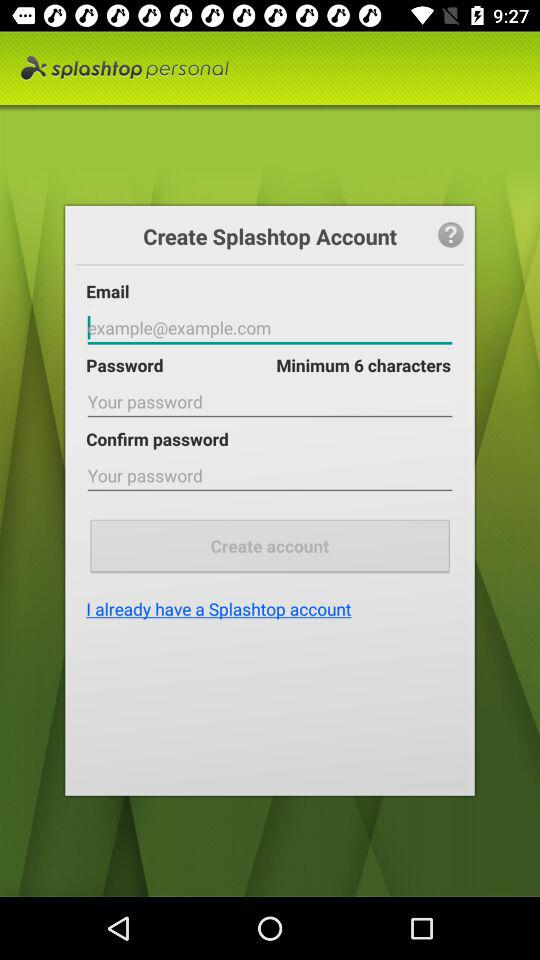What is the email address? The email address is example@example.com. 